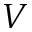Convert formula to latex. <formula><loc_0><loc_0><loc_500><loc_500>V</formula> 